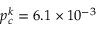<formula> <loc_0><loc_0><loc_500><loc_500>p _ { c } ^ { k } = 6 . 1 \times 1 0 ^ { - 3 }</formula> 